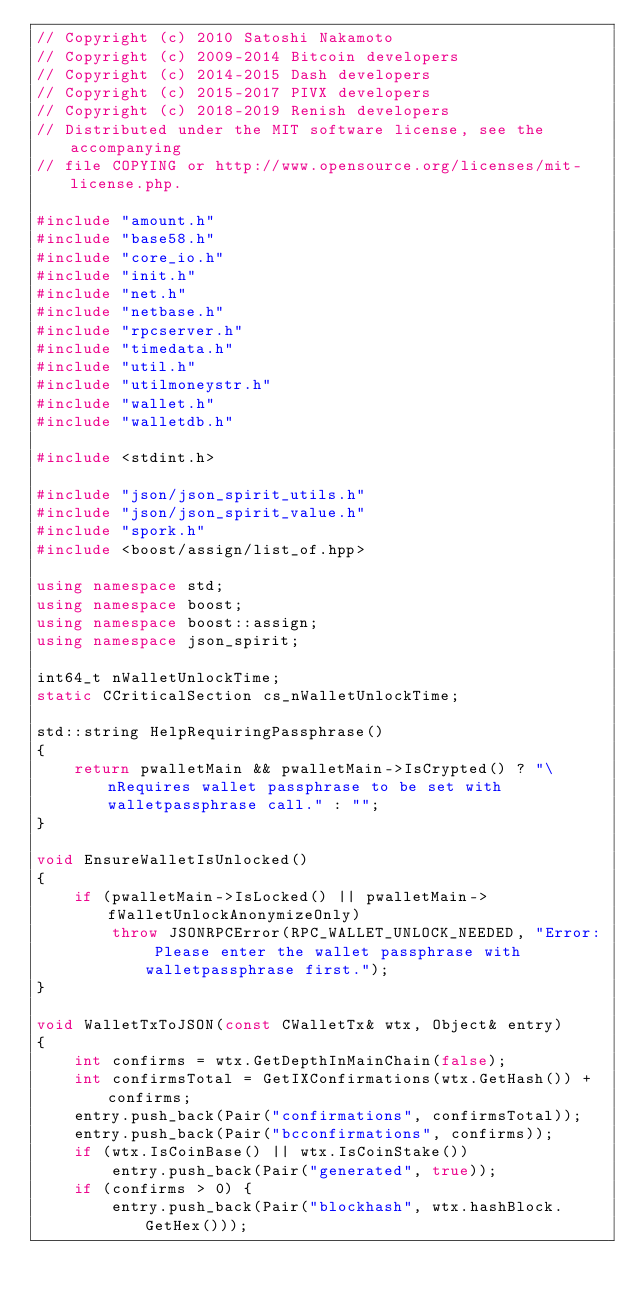<code> <loc_0><loc_0><loc_500><loc_500><_C++_>// Copyright (c) 2010 Satoshi Nakamoto
// Copyright (c) 2009-2014 Bitcoin developers
// Copyright (c) 2014-2015 Dash developers
// Copyright (c) 2015-2017 PIVX developers 
// Copyright (c) 2018-2019 Renish developers
// Distributed under the MIT software license, see the accompanying
// file COPYING or http://www.opensource.org/licenses/mit-license.php.

#include "amount.h"
#include "base58.h"
#include "core_io.h"
#include "init.h"
#include "net.h"
#include "netbase.h"
#include "rpcserver.h"
#include "timedata.h"
#include "util.h"
#include "utilmoneystr.h"
#include "wallet.h"
#include "walletdb.h"

#include <stdint.h>

#include "json/json_spirit_utils.h"
#include "json/json_spirit_value.h"
#include "spork.h"
#include <boost/assign/list_of.hpp>

using namespace std;
using namespace boost;
using namespace boost::assign;
using namespace json_spirit;

int64_t nWalletUnlockTime;
static CCriticalSection cs_nWalletUnlockTime;

std::string HelpRequiringPassphrase()
{
    return pwalletMain && pwalletMain->IsCrypted() ? "\nRequires wallet passphrase to be set with walletpassphrase call." : "";
}

void EnsureWalletIsUnlocked()
{
    if (pwalletMain->IsLocked() || pwalletMain->fWalletUnlockAnonymizeOnly)
        throw JSONRPCError(RPC_WALLET_UNLOCK_NEEDED, "Error: Please enter the wallet passphrase with walletpassphrase first.");
}

void WalletTxToJSON(const CWalletTx& wtx, Object& entry)
{
    int confirms = wtx.GetDepthInMainChain(false);
    int confirmsTotal = GetIXConfirmations(wtx.GetHash()) + confirms;
    entry.push_back(Pair("confirmations", confirmsTotal));
    entry.push_back(Pair("bcconfirmations", confirms));
    if (wtx.IsCoinBase() || wtx.IsCoinStake())
        entry.push_back(Pair("generated", true));
    if (confirms > 0) {
        entry.push_back(Pair("blockhash", wtx.hashBlock.GetHex()));</code> 